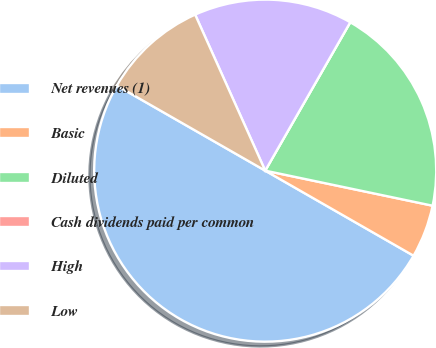Convert chart to OTSL. <chart><loc_0><loc_0><loc_500><loc_500><pie_chart><fcel>Net revenues (1)<fcel>Basic<fcel>Diluted<fcel>Cash dividends paid per common<fcel>High<fcel>Low<nl><fcel>49.99%<fcel>5.0%<fcel>20.0%<fcel>0.0%<fcel>15.0%<fcel>10.0%<nl></chart> 